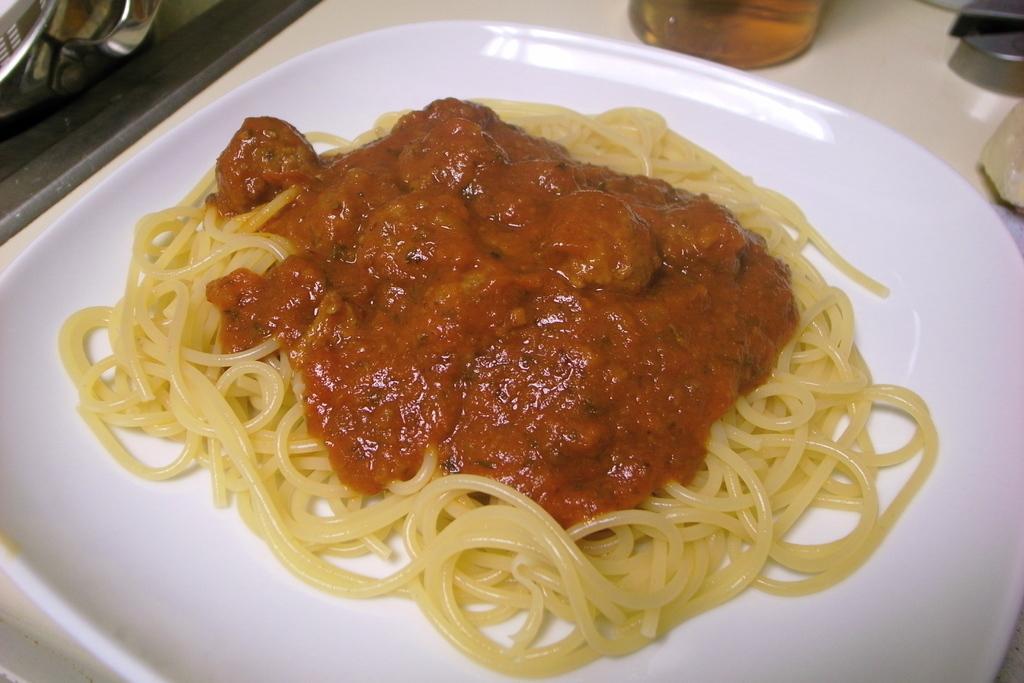Please provide a concise description of this image. In this image we can see food in a plate which is on a platform. At the top of the image we can see a glass with liquid which is truncated. 